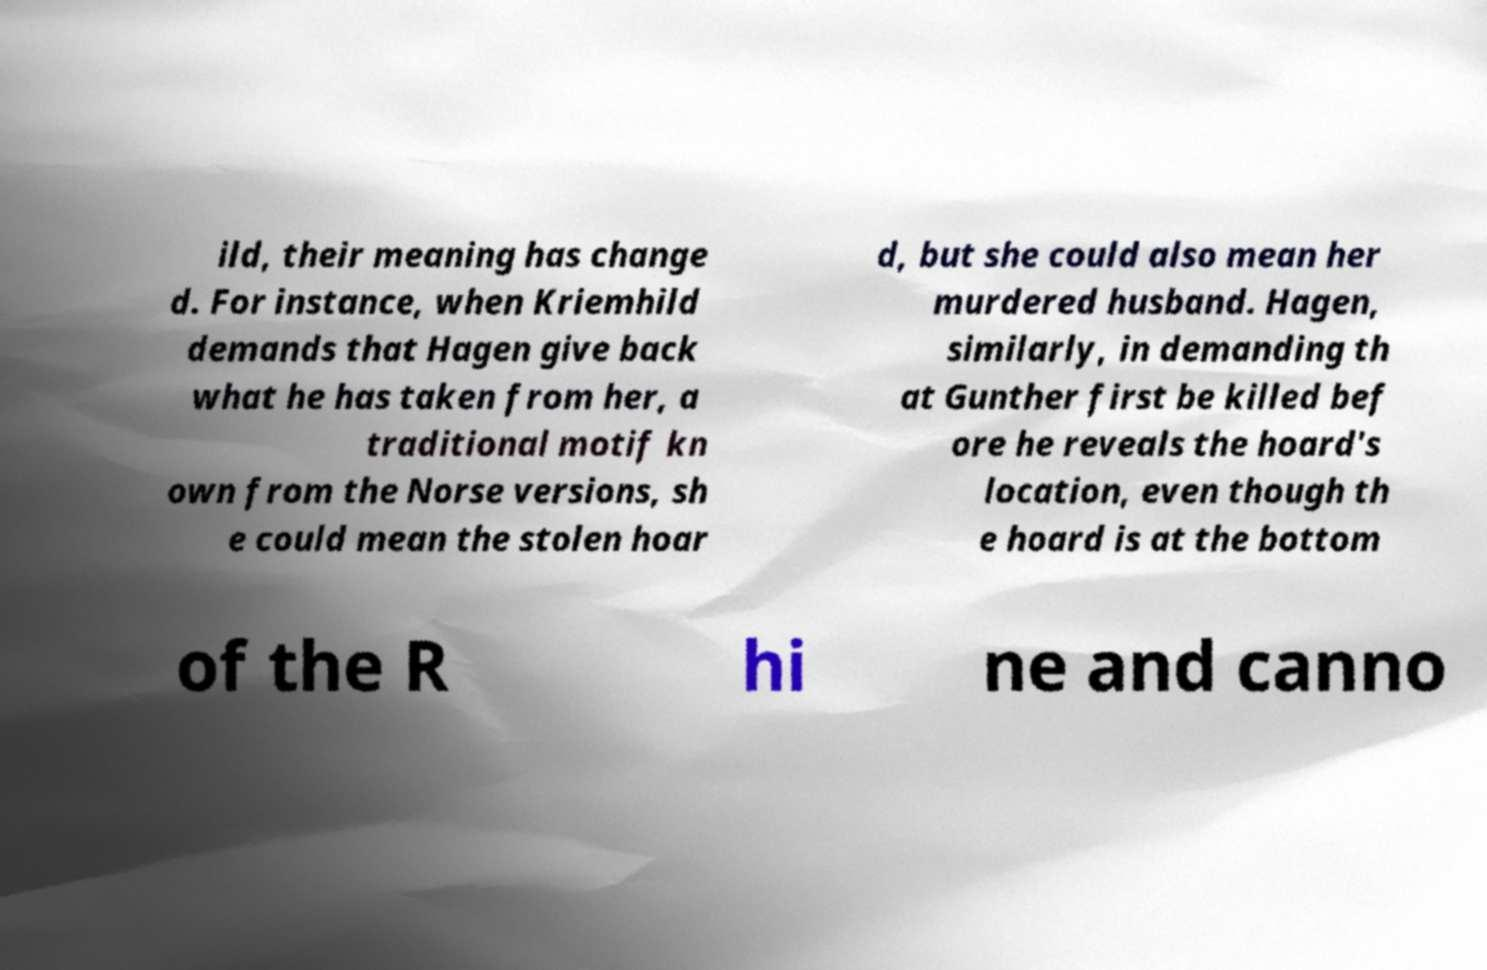Please read and relay the text visible in this image. What does it say? ild, their meaning has change d. For instance, when Kriemhild demands that Hagen give back what he has taken from her, a traditional motif kn own from the Norse versions, sh e could mean the stolen hoar d, but she could also mean her murdered husband. Hagen, similarly, in demanding th at Gunther first be killed bef ore he reveals the hoard's location, even though th e hoard is at the bottom of the R hi ne and canno 